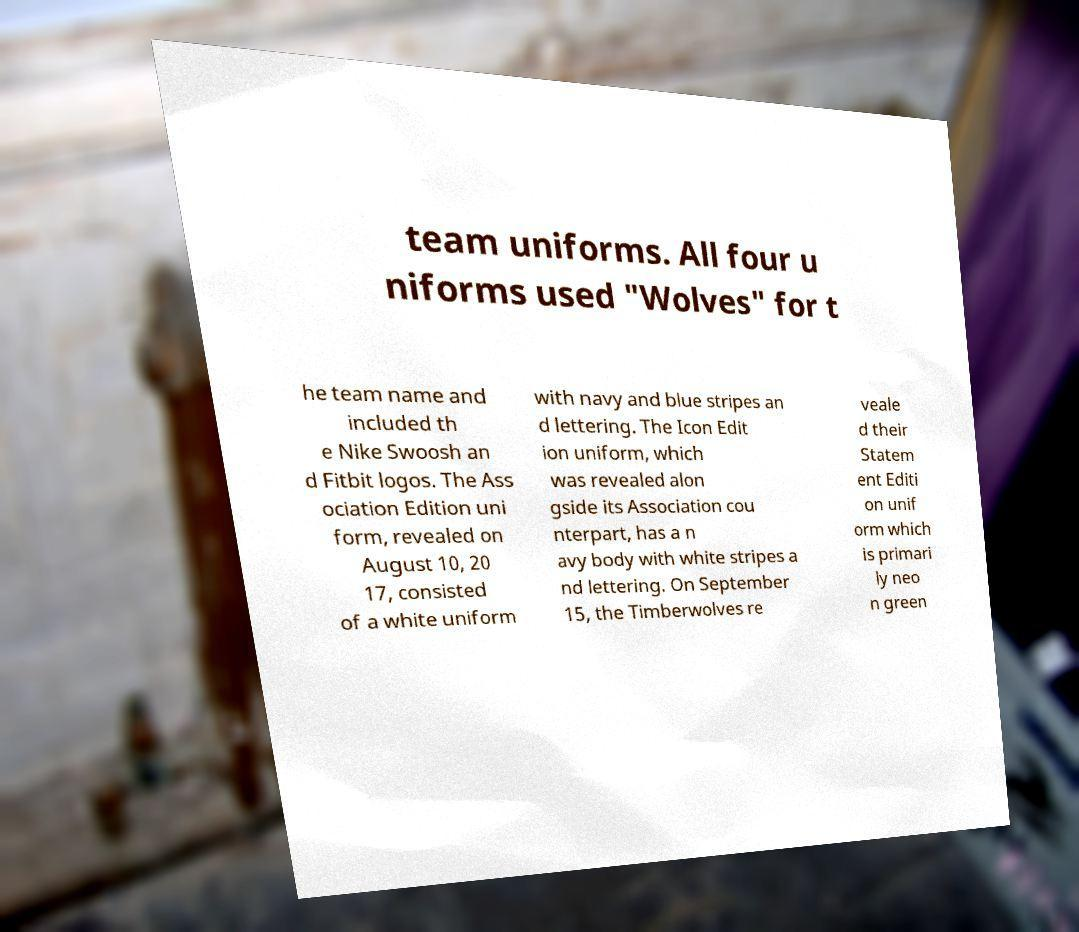I need the written content from this picture converted into text. Can you do that? team uniforms. All four u niforms used "Wolves" for t he team name and included th e Nike Swoosh an d Fitbit logos. The Ass ociation Edition uni form, revealed on August 10, 20 17, consisted of a white uniform with navy and blue stripes an d lettering. The Icon Edit ion uniform, which was revealed alon gside its Association cou nterpart, has a n avy body with white stripes a nd lettering. On September 15, the Timberwolves re veale d their Statem ent Editi on unif orm which is primari ly neo n green 